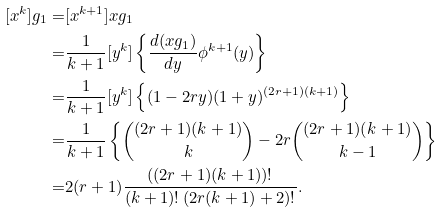Convert formula to latex. <formula><loc_0><loc_0><loc_500><loc_500>[ x ^ { k } ] g _ { 1 } = & [ x ^ { k + 1 } ] x g _ { 1 } \\ = & \frac { 1 } { k + 1 } [ y ^ { k } ] \left \{ \frac { d ( x g _ { 1 } ) } { d y } \phi ^ { k + 1 } ( y ) \right \} \\ = & \frac { 1 } { k + 1 } [ y ^ { k } ] \left \{ ( 1 - 2 r y ) ( 1 + y ) ^ { ( 2 r + 1 ) ( k + 1 ) } \right \} \\ = & \frac { 1 } { k + 1 } \left \{ \binom { ( 2 r + 1 ) ( k + 1 ) } { k } - 2 r \binom { ( 2 r + 1 ) ( k + 1 ) } { k - 1 } \right \} \\ = & 2 ( r + 1 ) \frac { ( ( 2 r + 1 ) ( k + 1 ) ) ! } { ( k + 1 ) ! \, ( 2 r ( k + 1 ) + 2 ) ! } .</formula> 